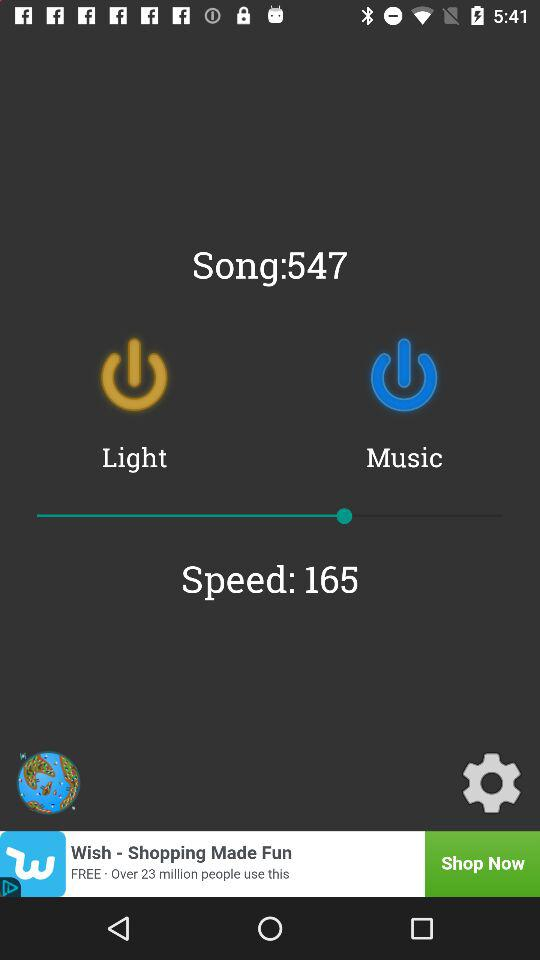What is the speed of the song? The speed of the song is 165. 